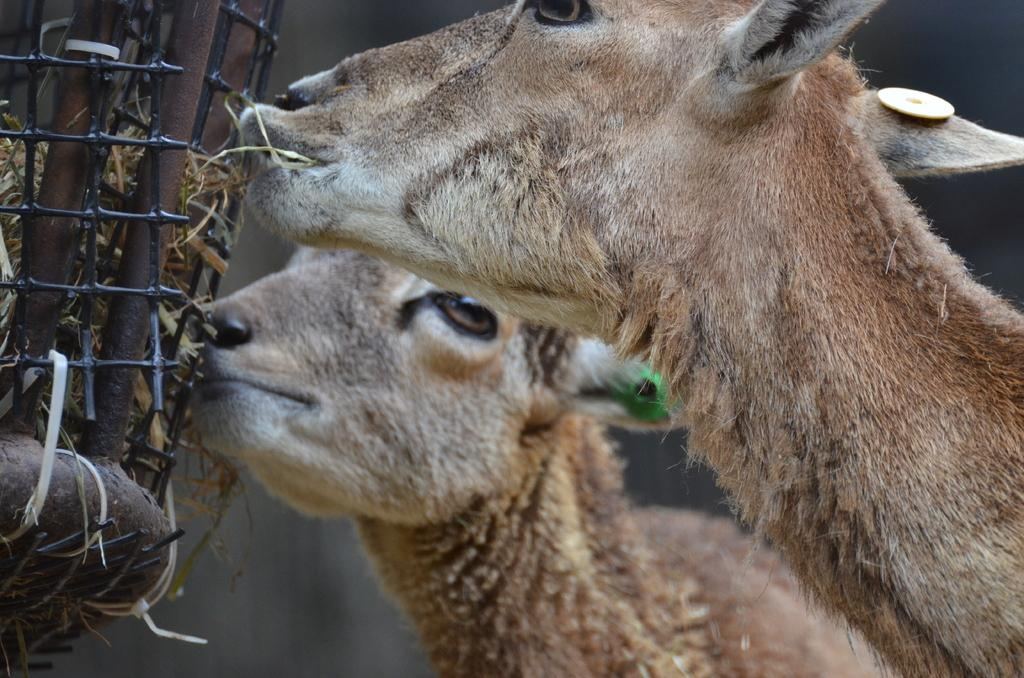What types of living organisms are in the image? There are animals in the image. Can you describe the object on the left side of the image? Unfortunately, the provided facts do not give any information about the object on the left side of the image. What type of form can be seen being dropped in the image? There is no form being dropped in the image. What type of work is being performed by the animals in the image? The provided facts do not give any information about the animals performing any work in the image. 